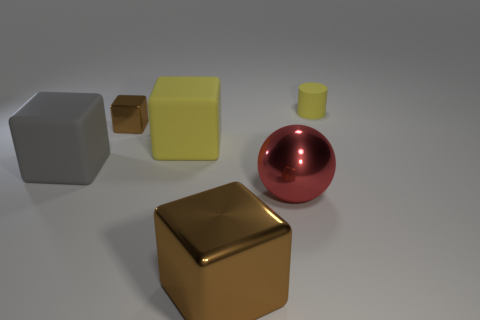Subtract all big blocks. How many blocks are left? 1 Add 3 gray cubes. How many objects exist? 9 Subtract all purple cubes. Subtract all blue cylinders. How many cubes are left? 4 Subtract all cubes. How many objects are left? 2 Add 4 yellow rubber cylinders. How many yellow rubber cylinders are left? 5 Add 5 cyan blocks. How many cyan blocks exist? 5 Subtract 0 cyan blocks. How many objects are left? 6 Subtract all large metallic objects. Subtract all yellow rubber cylinders. How many objects are left? 3 